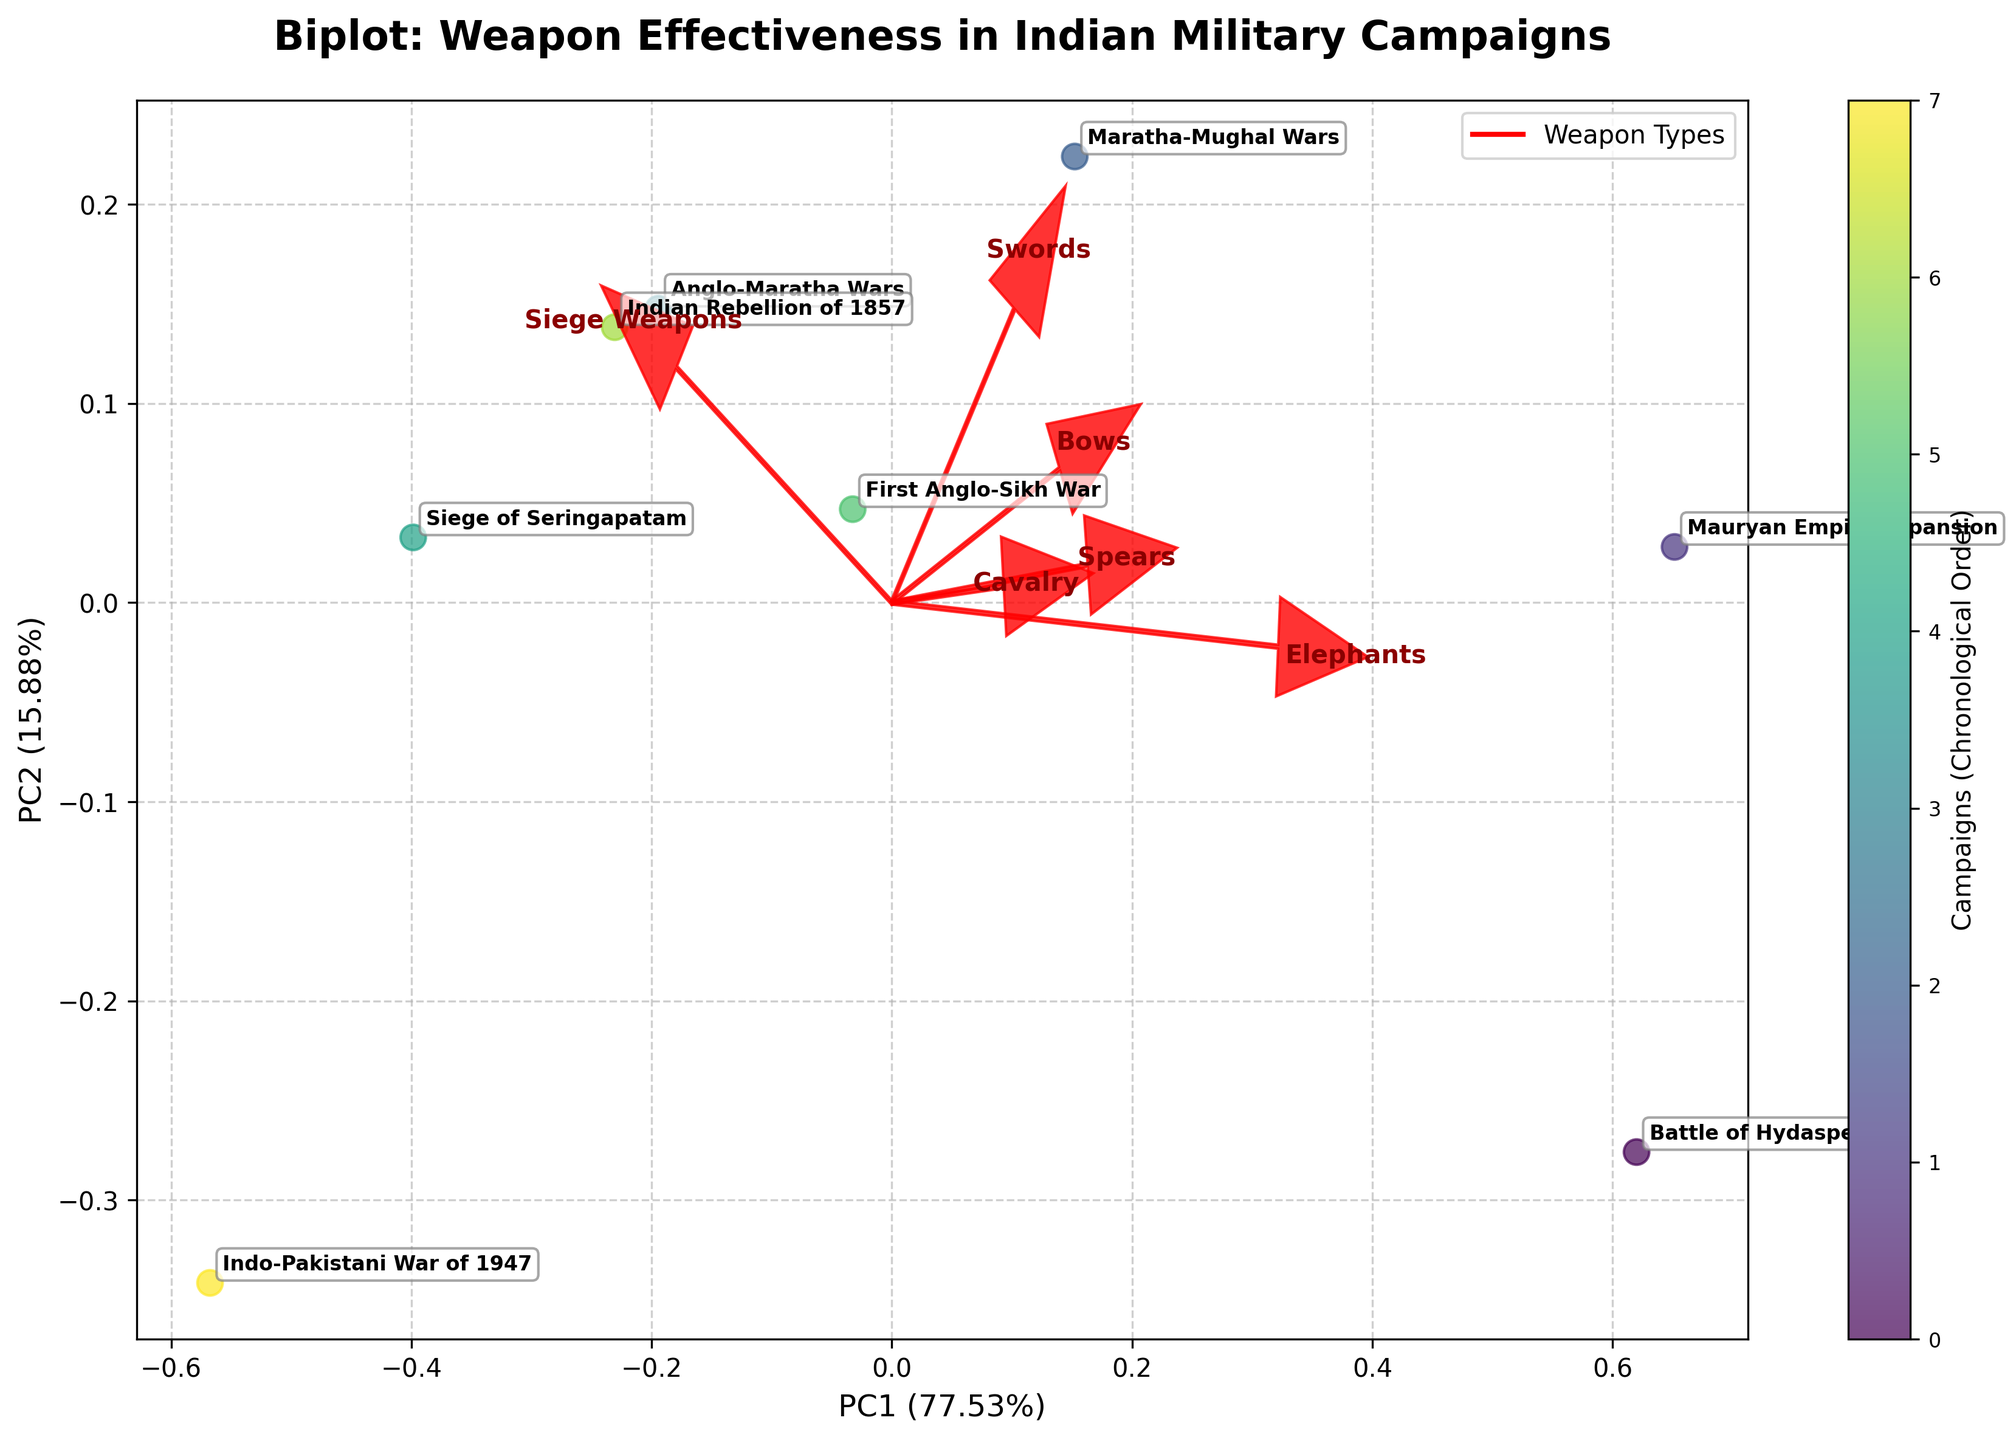What are the two axes of the biplot labeled as? The axes are labeled based on the principal components calculated through PCA, with the x-axis representing PC1 indicating its explained variance percentage, and the y-axis representing PC2 with its corresponding percentage.
Answer: PC1 (%), PC2 (%) Which weapon type has the strongest influence along PC1? Look at the arrows representing the loadings of the weapon types and check which arrow has the highest (most extended) component along the horizontal axis (PC1).
Answer: Swords Which two military campaigns are closest to each other on the biplot? By examining the positions of the campaign labels on the plot, identify the pair that have their points nearest to each other in the reduced-dimensionality space defined by PC1 and PC2.
Answer: Anglo-Maratha Wars, Indian Rebellion of 1857 Which campaign appears to be most influenced by Elephants according to the biplot? Find the direction of the arrow labeled 'Elephants' and look for the campaign point that lies closest or projects farthest along that direction.
Answer: Mauryan Empire Expansion Which campaign is the outlier in terms of effective use of weapon types, and in which direction is it significantly different? Determine the campaign point that is most distant from the others, and check the direction indicating which principal component (PC1 or PC2) it diverges along.
Answer: Indo-Pakistani War of 1947, different in the direction of PC1 What can be inferred about Siege Weapons' role in the Siege of Seringapatam from the biplot? Identify the position of the Siege of Seringapatam point relative to the arrow representing Siege Weapons. If it aligns closely with the direction of the arrow, it indicates a high influence.
Answer: High influence Is the effectiveness of Cavalry more similar to Swords or Spears based on the biplot? Compare the directions and lengths of the arrows for Cavalry, Swords, and Spears to see which two are more closely aligned, indicating a similarity in effectiveness.
Answer: Swords Which component (PC1 or PC2) explains a higher proportion of the variance based on the labels in the biplot? Compare the annotated percentages on the labels of PC1 and PC2 to determine which one is higher.
Answer: PC1 How does the effectiveness of Elephants contrast between the Battle of Hydaspes and the Indo-Pakistani War of 1947? Locate the positions of the two campaigns on the biplot and examine their alignment relative to the Elephants arrow, noting which campaign is closer to the direction indicating higher influence.
Answer: Battle of Hydaspes has higher effectiveness with Elephants Which weapon type is moderately influential across most principal components compared to others? Assess the lengths of the arrows representing the weapon loadings. The one with a moderate-length arrow across PC1 and PC2 indicates moderate influence.
Answer: Spears 